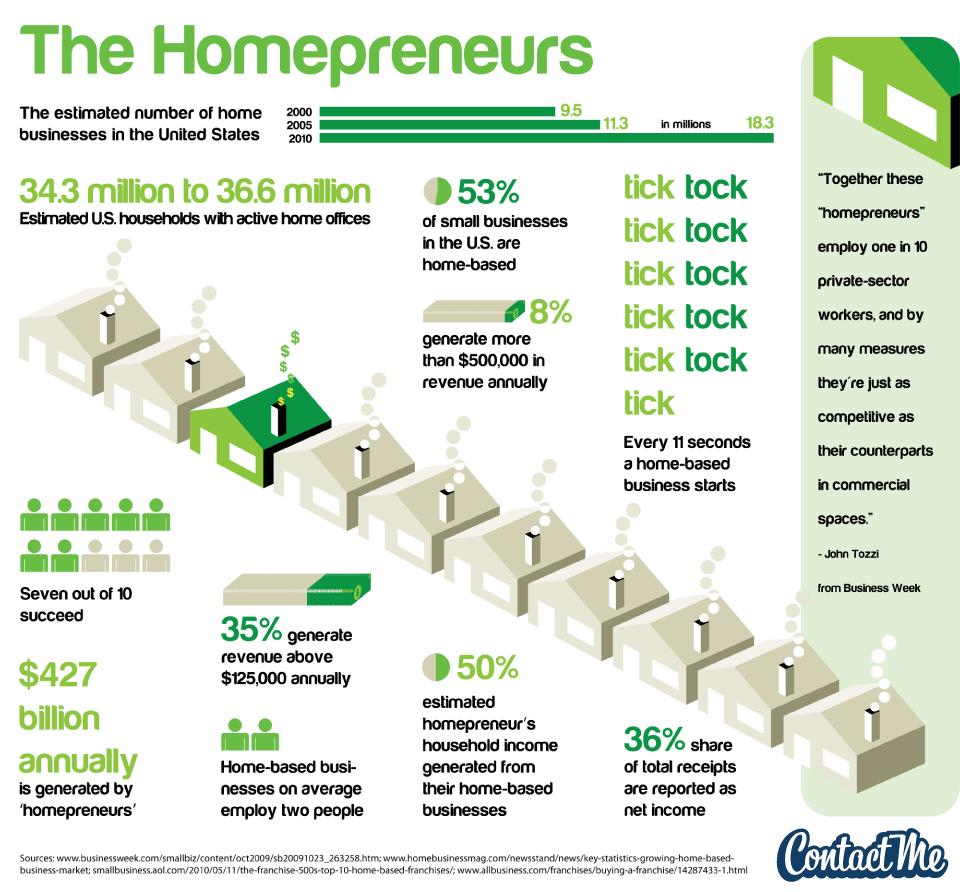Highlight a few significant elements in this photo. A home-based business can earn between 35% and 50% of its total income, with the exact percentage depending on various factors such as the type of business, industry standards, and the individual's marketing and sales strategies. 